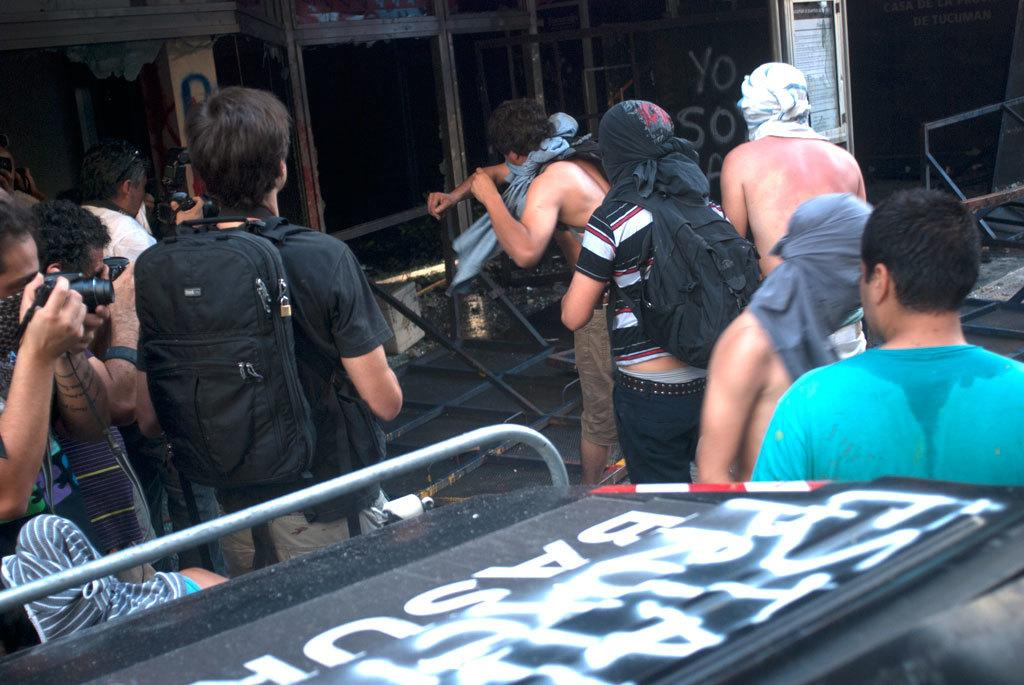How many people are in the group that is visible in the image? There is a group of people in the image, but the exact number is not specified. What are some people in the group wearing? Some people in the group are wearing bags. What are some people in the group holding? Some people in the group are holding cameras. What type of objects can be seen in the image besides people? There are boards and other objects present in the image. What type of pet can be seen in the image? There is no pet visible in the image. What color is the lipstick on the person in the image? There is no lipstick or person mentioned in the provided facts, so we cannot answer this question. 